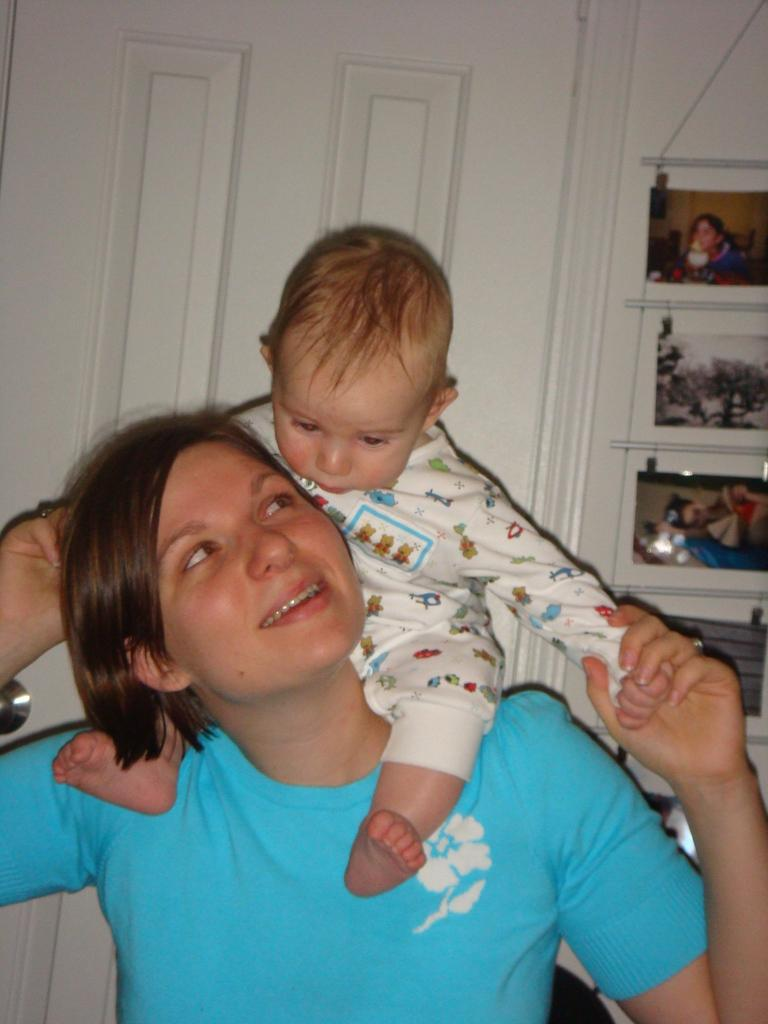What is the woman in the image doing? The woman is holding a baby in the image. What can be seen in the background of the image? There are photos on the wall and a white door in the background of the image. What type of alarm is going off in the image? There is no alarm present in the image. What mathematical operation is being performed with the baby in the image? There is no addition or any other mathematical operation being performed with the baby in the image. 